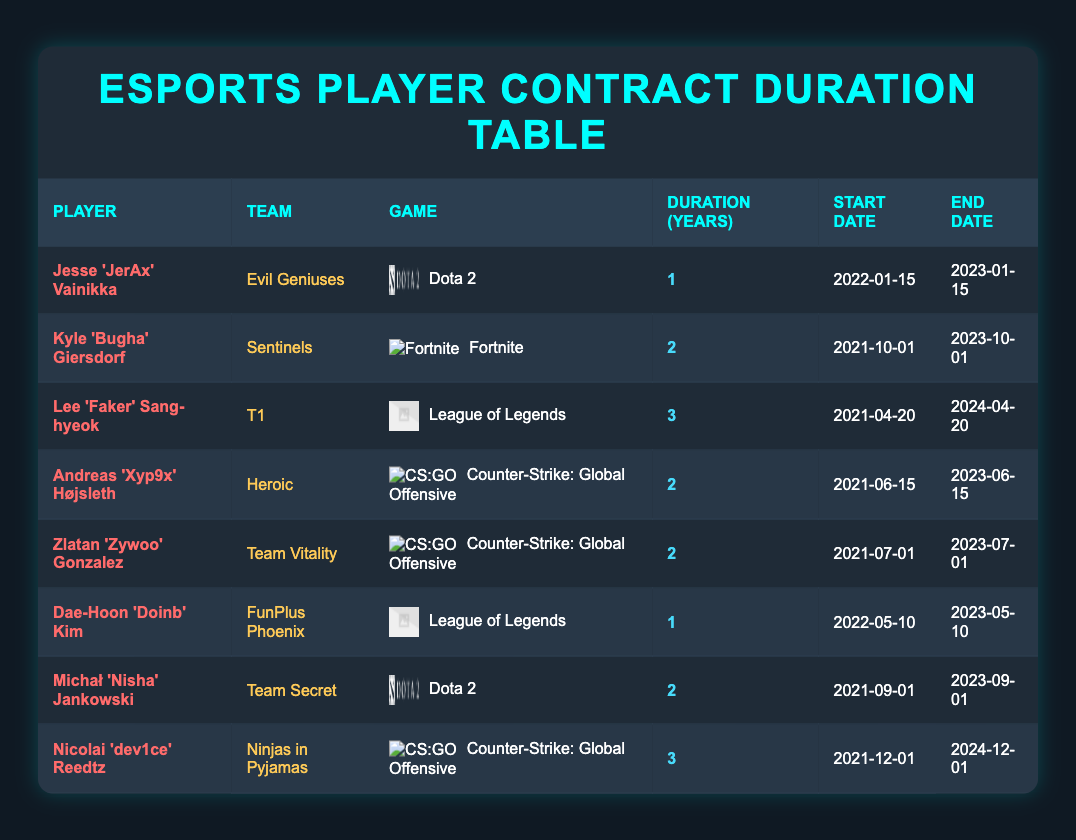What is the contract duration of Jesse 'JerAx' Vainikka? The table lists Jesse 'JerAx' Vainikka under the column for contract duration, showing that his contract lasts for 1 year.
Answer: 1 year How many players have contracts lasting for 2 years? By examining the contract duration column, there are 4 players with contracts that last for 2 years: Kyle 'Bugha' Giersdorf, Andreas 'Xyp9x' Højsleth, Zlatan 'Zywoo' Gonzalez, and Michał 'Nisha' Jankowski.
Answer: 4 players Is Lee 'Faker' Sang-hyeok's contract longer than Dae-Hoon 'Doinb' Kim's contract? Lee 'Faker' Sang-hyeok has a contract duration of 3 years, while Dae-Hoon 'Doinb' Kim has a contract duration of 1 year. Therefore, Lee 'Faker's contract is indeed longer.
Answer: Yes What is the average contract duration for all the players listed? The contract durations are 1, 2, 3, 2, 2, 1, 2, and 3 years. Summing these values gives 1+2+3+2+2+1+2+3 = 16 years. There are 8 players, so the average duration is 16/8 = 2 years.
Answer: 2 years Which player has the longest contract duration, and what is that duration? By reviewing the contract duration column, Lee 'Faker' Sang-hyeok and Nicolai 'dev1ce' Reedtz both have the longest contract duration of 3 years.
Answer: Lee 'Faker' Sang-hyeok, 3 years What is the earliest start date of a player's contract? The start dates listed are: 2022-01-15, 2021-10-01, 2021-04-20, 2021-06-15, 2021-07-01, 2022-05-10, 2021-09-01, and 2021-12-01. Among these, 2021-04-20 is the earliest date.
Answer: 2021-04-20 How many players have contracts that expire in 2023? By checking the end dates, three players' contracts end in 2023, these are Jesse 'JerAx' Vainikka, Andreas 'Xyp9x' Højsleth, and Dae-Hoon 'Doinb' Kim.
Answer: 3 players Is there a player whose contract ends later than April 2024? The player Lee 'Faker' Sang-hyeok's contract ends on April 20, 2024. Thus, his contract does not end later than that date, and Nicolai 'dev1ce' Reedtz's contract ends on December 1, 2024, hence there is a player whose contract ends later.
Answer: Yes 